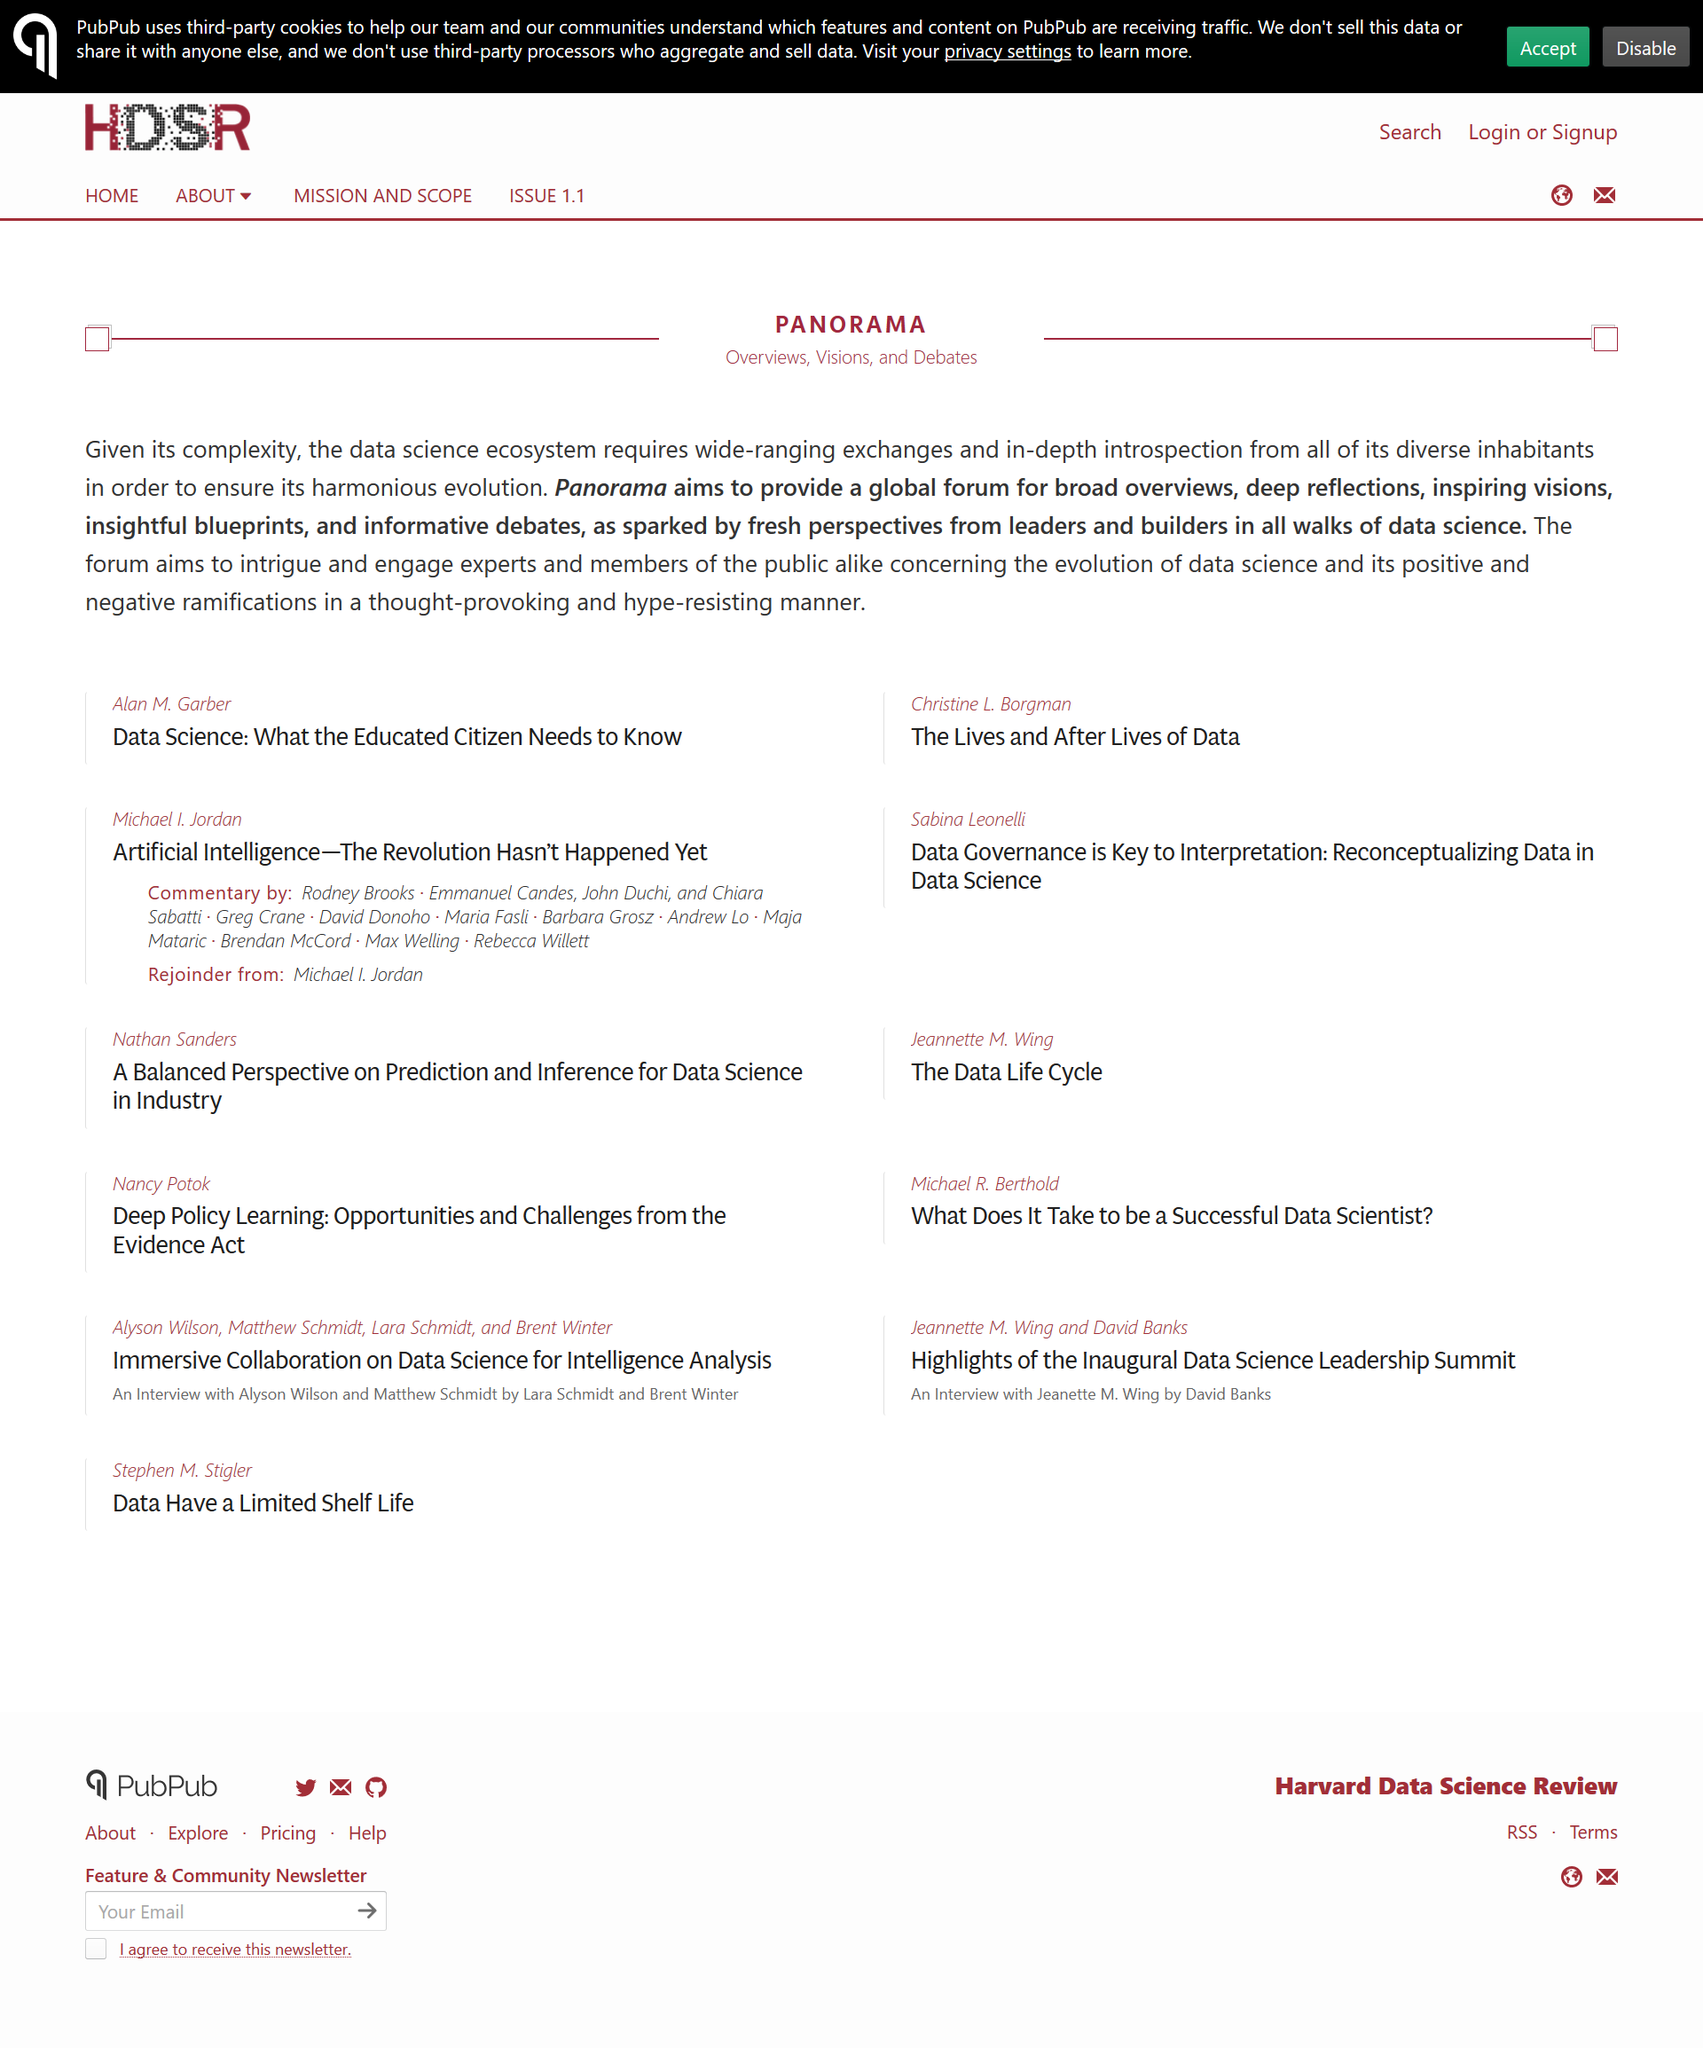Specify some key components in this picture. The title of the page is "Panorama". Panorama provides a global forum for discussion and debate. The subheading on the page is overviews, visions, and debates. 